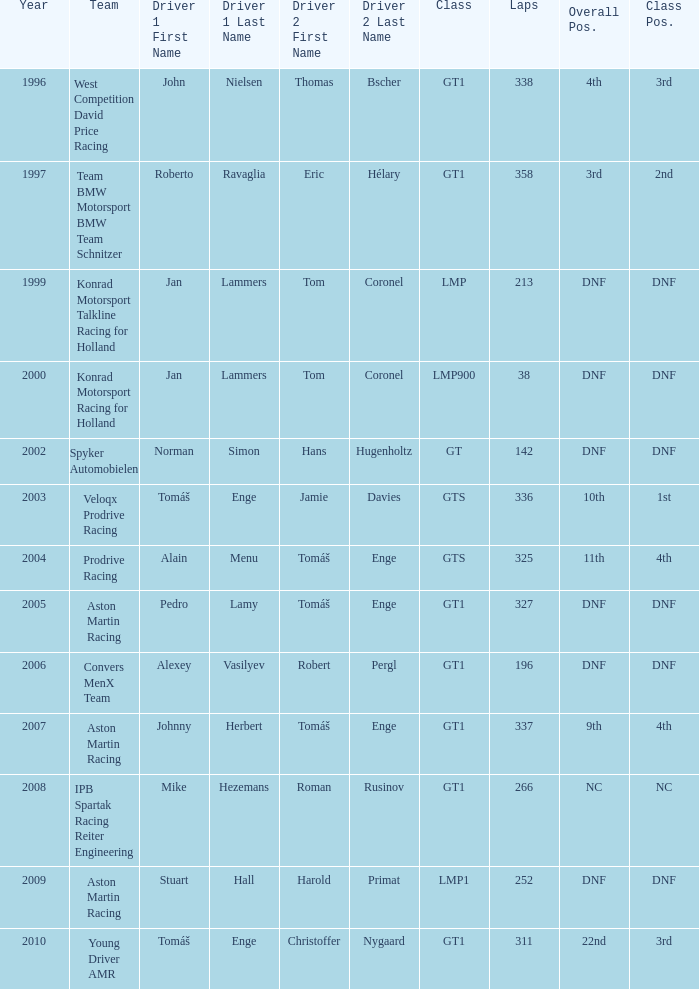Which team finished 3rd in class with 337 laps before 2008? West Competition David Price Racing. 